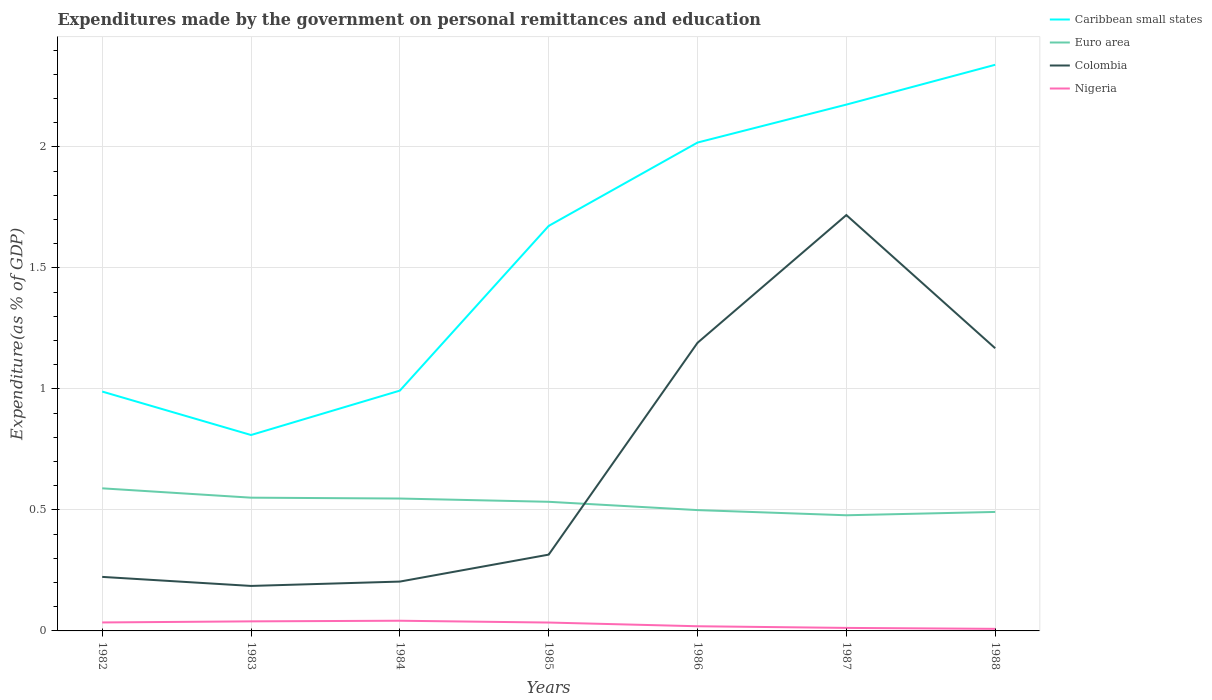Is the number of lines equal to the number of legend labels?
Provide a short and direct response. Yes. Across all years, what is the maximum expenditures made by the government on personal remittances and education in Nigeria?
Your answer should be compact. 0.01. In which year was the expenditures made by the government on personal remittances and education in Caribbean small states maximum?
Keep it short and to the point. 1983. What is the total expenditures made by the government on personal remittances and education in Colombia in the graph?
Offer a terse response. -1.4. What is the difference between the highest and the second highest expenditures made by the government on personal remittances and education in Euro area?
Provide a succinct answer. 0.11. How many years are there in the graph?
Your answer should be very brief. 7. What is the difference between two consecutive major ticks on the Y-axis?
Give a very brief answer. 0.5. Are the values on the major ticks of Y-axis written in scientific E-notation?
Offer a very short reply. No. Does the graph contain any zero values?
Your response must be concise. No. Where does the legend appear in the graph?
Ensure brevity in your answer.  Top right. How many legend labels are there?
Your answer should be compact. 4. What is the title of the graph?
Provide a short and direct response. Expenditures made by the government on personal remittances and education. What is the label or title of the Y-axis?
Make the answer very short. Expenditure(as % of GDP). What is the Expenditure(as % of GDP) in Caribbean small states in 1982?
Offer a very short reply. 0.99. What is the Expenditure(as % of GDP) of Euro area in 1982?
Offer a terse response. 0.59. What is the Expenditure(as % of GDP) in Colombia in 1982?
Provide a succinct answer. 0.22. What is the Expenditure(as % of GDP) in Nigeria in 1982?
Your response must be concise. 0.04. What is the Expenditure(as % of GDP) in Caribbean small states in 1983?
Your response must be concise. 0.81. What is the Expenditure(as % of GDP) in Euro area in 1983?
Provide a succinct answer. 0.55. What is the Expenditure(as % of GDP) in Colombia in 1983?
Make the answer very short. 0.19. What is the Expenditure(as % of GDP) of Nigeria in 1983?
Your response must be concise. 0.04. What is the Expenditure(as % of GDP) in Caribbean small states in 1984?
Provide a succinct answer. 0.99. What is the Expenditure(as % of GDP) of Euro area in 1984?
Ensure brevity in your answer.  0.55. What is the Expenditure(as % of GDP) of Colombia in 1984?
Make the answer very short. 0.2. What is the Expenditure(as % of GDP) in Nigeria in 1984?
Provide a succinct answer. 0.04. What is the Expenditure(as % of GDP) of Caribbean small states in 1985?
Your answer should be compact. 1.67. What is the Expenditure(as % of GDP) of Euro area in 1985?
Offer a terse response. 0.53. What is the Expenditure(as % of GDP) of Colombia in 1985?
Ensure brevity in your answer.  0.32. What is the Expenditure(as % of GDP) of Nigeria in 1985?
Provide a short and direct response. 0.03. What is the Expenditure(as % of GDP) in Caribbean small states in 1986?
Offer a terse response. 2.02. What is the Expenditure(as % of GDP) of Euro area in 1986?
Make the answer very short. 0.5. What is the Expenditure(as % of GDP) in Colombia in 1986?
Keep it short and to the point. 1.19. What is the Expenditure(as % of GDP) of Nigeria in 1986?
Give a very brief answer. 0.02. What is the Expenditure(as % of GDP) of Caribbean small states in 1987?
Offer a terse response. 2.17. What is the Expenditure(as % of GDP) in Euro area in 1987?
Your answer should be very brief. 0.48. What is the Expenditure(as % of GDP) of Colombia in 1987?
Your answer should be very brief. 1.72. What is the Expenditure(as % of GDP) in Nigeria in 1987?
Your answer should be very brief. 0.01. What is the Expenditure(as % of GDP) in Caribbean small states in 1988?
Provide a short and direct response. 2.34. What is the Expenditure(as % of GDP) in Euro area in 1988?
Your response must be concise. 0.49. What is the Expenditure(as % of GDP) of Colombia in 1988?
Your response must be concise. 1.17. What is the Expenditure(as % of GDP) in Nigeria in 1988?
Your answer should be very brief. 0.01. Across all years, what is the maximum Expenditure(as % of GDP) in Caribbean small states?
Your response must be concise. 2.34. Across all years, what is the maximum Expenditure(as % of GDP) of Euro area?
Your answer should be very brief. 0.59. Across all years, what is the maximum Expenditure(as % of GDP) in Colombia?
Keep it short and to the point. 1.72. Across all years, what is the maximum Expenditure(as % of GDP) of Nigeria?
Keep it short and to the point. 0.04. Across all years, what is the minimum Expenditure(as % of GDP) of Caribbean small states?
Make the answer very short. 0.81. Across all years, what is the minimum Expenditure(as % of GDP) in Euro area?
Offer a very short reply. 0.48. Across all years, what is the minimum Expenditure(as % of GDP) of Colombia?
Provide a succinct answer. 0.19. Across all years, what is the minimum Expenditure(as % of GDP) of Nigeria?
Make the answer very short. 0.01. What is the total Expenditure(as % of GDP) in Caribbean small states in the graph?
Provide a short and direct response. 11. What is the total Expenditure(as % of GDP) in Euro area in the graph?
Offer a terse response. 3.69. What is the total Expenditure(as % of GDP) of Colombia in the graph?
Offer a very short reply. 5.01. What is the total Expenditure(as % of GDP) in Nigeria in the graph?
Make the answer very short. 0.19. What is the difference between the Expenditure(as % of GDP) in Caribbean small states in 1982 and that in 1983?
Provide a succinct answer. 0.18. What is the difference between the Expenditure(as % of GDP) of Euro area in 1982 and that in 1983?
Offer a terse response. 0.04. What is the difference between the Expenditure(as % of GDP) of Colombia in 1982 and that in 1983?
Give a very brief answer. 0.04. What is the difference between the Expenditure(as % of GDP) in Nigeria in 1982 and that in 1983?
Offer a very short reply. -0. What is the difference between the Expenditure(as % of GDP) in Caribbean small states in 1982 and that in 1984?
Provide a short and direct response. -0. What is the difference between the Expenditure(as % of GDP) in Euro area in 1982 and that in 1984?
Ensure brevity in your answer.  0.04. What is the difference between the Expenditure(as % of GDP) in Colombia in 1982 and that in 1984?
Ensure brevity in your answer.  0.02. What is the difference between the Expenditure(as % of GDP) of Nigeria in 1982 and that in 1984?
Your answer should be very brief. -0.01. What is the difference between the Expenditure(as % of GDP) of Caribbean small states in 1982 and that in 1985?
Offer a terse response. -0.68. What is the difference between the Expenditure(as % of GDP) in Euro area in 1982 and that in 1985?
Keep it short and to the point. 0.06. What is the difference between the Expenditure(as % of GDP) of Colombia in 1982 and that in 1985?
Offer a terse response. -0.09. What is the difference between the Expenditure(as % of GDP) of Caribbean small states in 1982 and that in 1986?
Make the answer very short. -1.03. What is the difference between the Expenditure(as % of GDP) in Euro area in 1982 and that in 1986?
Offer a terse response. 0.09. What is the difference between the Expenditure(as % of GDP) in Colombia in 1982 and that in 1986?
Offer a terse response. -0.97. What is the difference between the Expenditure(as % of GDP) of Nigeria in 1982 and that in 1986?
Offer a very short reply. 0.02. What is the difference between the Expenditure(as % of GDP) in Caribbean small states in 1982 and that in 1987?
Keep it short and to the point. -1.19. What is the difference between the Expenditure(as % of GDP) in Euro area in 1982 and that in 1987?
Your answer should be compact. 0.11. What is the difference between the Expenditure(as % of GDP) in Colombia in 1982 and that in 1987?
Ensure brevity in your answer.  -1.5. What is the difference between the Expenditure(as % of GDP) of Nigeria in 1982 and that in 1987?
Make the answer very short. 0.02. What is the difference between the Expenditure(as % of GDP) of Caribbean small states in 1982 and that in 1988?
Give a very brief answer. -1.35. What is the difference between the Expenditure(as % of GDP) in Euro area in 1982 and that in 1988?
Your response must be concise. 0.1. What is the difference between the Expenditure(as % of GDP) of Colombia in 1982 and that in 1988?
Keep it short and to the point. -0.94. What is the difference between the Expenditure(as % of GDP) in Nigeria in 1982 and that in 1988?
Your answer should be compact. 0.03. What is the difference between the Expenditure(as % of GDP) of Caribbean small states in 1983 and that in 1984?
Your answer should be very brief. -0.18. What is the difference between the Expenditure(as % of GDP) of Euro area in 1983 and that in 1984?
Provide a succinct answer. 0. What is the difference between the Expenditure(as % of GDP) in Colombia in 1983 and that in 1984?
Provide a short and direct response. -0.02. What is the difference between the Expenditure(as % of GDP) of Nigeria in 1983 and that in 1984?
Make the answer very short. -0. What is the difference between the Expenditure(as % of GDP) of Caribbean small states in 1983 and that in 1985?
Your answer should be compact. -0.86. What is the difference between the Expenditure(as % of GDP) in Euro area in 1983 and that in 1985?
Offer a very short reply. 0.02. What is the difference between the Expenditure(as % of GDP) in Colombia in 1983 and that in 1985?
Provide a succinct answer. -0.13. What is the difference between the Expenditure(as % of GDP) of Nigeria in 1983 and that in 1985?
Provide a succinct answer. 0. What is the difference between the Expenditure(as % of GDP) of Caribbean small states in 1983 and that in 1986?
Offer a very short reply. -1.21. What is the difference between the Expenditure(as % of GDP) of Euro area in 1983 and that in 1986?
Make the answer very short. 0.05. What is the difference between the Expenditure(as % of GDP) in Colombia in 1983 and that in 1986?
Provide a short and direct response. -1. What is the difference between the Expenditure(as % of GDP) of Nigeria in 1983 and that in 1986?
Keep it short and to the point. 0.02. What is the difference between the Expenditure(as % of GDP) of Caribbean small states in 1983 and that in 1987?
Make the answer very short. -1.37. What is the difference between the Expenditure(as % of GDP) of Euro area in 1983 and that in 1987?
Keep it short and to the point. 0.07. What is the difference between the Expenditure(as % of GDP) of Colombia in 1983 and that in 1987?
Your answer should be compact. -1.53. What is the difference between the Expenditure(as % of GDP) of Nigeria in 1983 and that in 1987?
Your response must be concise. 0.03. What is the difference between the Expenditure(as % of GDP) in Caribbean small states in 1983 and that in 1988?
Your answer should be very brief. -1.53. What is the difference between the Expenditure(as % of GDP) in Euro area in 1983 and that in 1988?
Your answer should be very brief. 0.06. What is the difference between the Expenditure(as % of GDP) in Colombia in 1983 and that in 1988?
Your answer should be very brief. -0.98. What is the difference between the Expenditure(as % of GDP) in Nigeria in 1983 and that in 1988?
Your answer should be compact. 0.03. What is the difference between the Expenditure(as % of GDP) of Caribbean small states in 1984 and that in 1985?
Your answer should be very brief. -0.68. What is the difference between the Expenditure(as % of GDP) in Euro area in 1984 and that in 1985?
Offer a very short reply. 0.01. What is the difference between the Expenditure(as % of GDP) in Colombia in 1984 and that in 1985?
Your answer should be very brief. -0.11. What is the difference between the Expenditure(as % of GDP) of Nigeria in 1984 and that in 1985?
Provide a short and direct response. 0.01. What is the difference between the Expenditure(as % of GDP) in Caribbean small states in 1984 and that in 1986?
Keep it short and to the point. -1.02. What is the difference between the Expenditure(as % of GDP) of Euro area in 1984 and that in 1986?
Ensure brevity in your answer.  0.05. What is the difference between the Expenditure(as % of GDP) in Colombia in 1984 and that in 1986?
Your answer should be compact. -0.99. What is the difference between the Expenditure(as % of GDP) in Nigeria in 1984 and that in 1986?
Make the answer very short. 0.02. What is the difference between the Expenditure(as % of GDP) of Caribbean small states in 1984 and that in 1987?
Your response must be concise. -1.18. What is the difference between the Expenditure(as % of GDP) of Euro area in 1984 and that in 1987?
Provide a short and direct response. 0.07. What is the difference between the Expenditure(as % of GDP) of Colombia in 1984 and that in 1987?
Keep it short and to the point. -1.51. What is the difference between the Expenditure(as % of GDP) in Nigeria in 1984 and that in 1987?
Provide a short and direct response. 0.03. What is the difference between the Expenditure(as % of GDP) in Caribbean small states in 1984 and that in 1988?
Provide a succinct answer. -1.35. What is the difference between the Expenditure(as % of GDP) in Euro area in 1984 and that in 1988?
Provide a succinct answer. 0.06. What is the difference between the Expenditure(as % of GDP) of Colombia in 1984 and that in 1988?
Keep it short and to the point. -0.96. What is the difference between the Expenditure(as % of GDP) of Nigeria in 1984 and that in 1988?
Provide a succinct answer. 0.03. What is the difference between the Expenditure(as % of GDP) in Caribbean small states in 1985 and that in 1986?
Your answer should be very brief. -0.34. What is the difference between the Expenditure(as % of GDP) in Euro area in 1985 and that in 1986?
Provide a short and direct response. 0.03. What is the difference between the Expenditure(as % of GDP) in Colombia in 1985 and that in 1986?
Ensure brevity in your answer.  -0.88. What is the difference between the Expenditure(as % of GDP) in Nigeria in 1985 and that in 1986?
Your response must be concise. 0.02. What is the difference between the Expenditure(as % of GDP) of Caribbean small states in 1985 and that in 1987?
Offer a terse response. -0.5. What is the difference between the Expenditure(as % of GDP) of Euro area in 1985 and that in 1987?
Your response must be concise. 0.06. What is the difference between the Expenditure(as % of GDP) of Colombia in 1985 and that in 1987?
Offer a very short reply. -1.4. What is the difference between the Expenditure(as % of GDP) of Nigeria in 1985 and that in 1987?
Offer a terse response. 0.02. What is the difference between the Expenditure(as % of GDP) of Caribbean small states in 1985 and that in 1988?
Give a very brief answer. -0.67. What is the difference between the Expenditure(as % of GDP) in Euro area in 1985 and that in 1988?
Your response must be concise. 0.04. What is the difference between the Expenditure(as % of GDP) in Colombia in 1985 and that in 1988?
Your response must be concise. -0.85. What is the difference between the Expenditure(as % of GDP) of Nigeria in 1985 and that in 1988?
Your answer should be compact. 0.03. What is the difference between the Expenditure(as % of GDP) of Caribbean small states in 1986 and that in 1987?
Give a very brief answer. -0.16. What is the difference between the Expenditure(as % of GDP) in Euro area in 1986 and that in 1987?
Provide a short and direct response. 0.02. What is the difference between the Expenditure(as % of GDP) in Colombia in 1986 and that in 1987?
Your response must be concise. -0.53. What is the difference between the Expenditure(as % of GDP) of Nigeria in 1986 and that in 1987?
Make the answer very short. 0.01. What is the difference between the Expenditure(as % of GDP) of Caribbean small states in 1986 and that in 1988?
Your answer should be compact. -0.32. What is the difference between the Expenditure(as % of GDP) in Euro area in 1986 and that in 1988?
Keep it short and to the point. 0.01. What is the difference between the Expenditure(as % of GDP) of Colombia in 1986 and that in 1988?
Offer a terse response. 0.02. What is the difference between the Expenditure(as % of GDP) in Nigeria in 1986 and that in 1988?
Your answer should be very brief. 0.01. What is the difference between the Expenditure(as % of GDP) in Caribbean small states in 1987 and that in 1988?
Offer a terse response. -0.16. What is the difference between the Expenditure(as % of GDP) of Euro area in 1987 and that in 1988?
Provide a short and direct response. -0.01. What is the difference between the Expenditure(as % of GDP) in Colombia in 1987 and that in 1988?
Offer a very short reply. 0.55. What is the difference between the Expenditure(as % of GDP) of Nigeria in 1987 and that in 1988?
Provide a succinct answer. 0. What is the difference between the Expenditure(as % of GDP) of Caribbean small states in 1982 and the Expenditure(as % of GDP) of Euro area in 1983?
Provide a short and direct response. 0.44. What is the difference between the Expenditure(as % of GDP) in Caribbean small states in 1982 and the Expenditure(as % of GDP) in Colombia in 1983?
Provide a succinct answer. 0.8. What is the difference between the Expenditure(as % of GDP) in Caribbean small states in 1982 and the Expenditure(as % of GDP) in Nigeria in 1983?
Offer a terse response. 0.95. What is the difference between the Expenditure(as % of GDP) of Euro area in 1982 and the Expenditure(as % of GDP) of Colombia in 1983?
Your response must be concise. 0.4. What is the difference between the Expenditure(as % of GDP) of Euro area in 1982 and the Expenditure(as % of GDP) of Nigeria in 1983?
Offer a very short reply. 0.55. What is the difference between the Expenditure(as % of GDP) in Colombia in 1982 and the Expenditure(as % of GDP) in Nigeria in 1983?
Offer a very short reply. 0.18. What is the difference between the Expenditure(as % of GDP) of Caribbean small states in 1982 and the Expenditure(as % of GDP) of Euro area in 1984?
Offer a very short reply. 0.44. What is the difference between the Expenditure(as % of GDP) of Caribbean small states in 1982 and the Expenditure(as % of GDP) of Colombia in 1984?
Ensure brevity in your answer.  0.79. What is the difference between the Expenditure(as % of GDP) of Caribbean small states in 1982 and the Expenditure(as % of GDP) of Nigeria in 1984?
Provide a succinct answer. 0.95. What is the difference between the Expenditure(as % of GDP) of Euro area in 1982 and the Expenditure(as % of GDP) of Colombia in 1984?
Offer a very short reply. 0.39. What is the difference between the Expenditure(as % of GDP) in Euro area in 1982 and the Expenditure(as % of GDP) in Nigeria in 1984?
Provide a short and direct response. 0.55. What is the difference between the Expenditure(as % of GDP) of Colombia in 1982 and the Expenditure(as % of GDP) of Nigeria in 1984?
Make the answer very short. 0.18. What is the difference between the Expenditure(as % of GDP) in Caribbean small states in 1982 and the Expenditure(as % of GDP) in Euro area in 1985?
Ensure brevity in your answer.  0.46. What is the difference between the Expenditure(as % of GDP) in Caribbean small states in 1982 and the Expenditure(as % of GDP) in Colombia in 1985?
Provide a short and direct response. 0.67. What is the difference between the Expenditure(as % of GDP) of Caribbean small states in 1982 and the Expenditure(as % of GDP) of Nigeria in 1985?
Keep it short and to the point. 0.95. What is the difference between the Expenditure(as % of GDP) in Euro area in 1982 and the Expenditure(as % of GDP) in Colombia in 1985?
Your answer should be compact. 0.27. What is the difference between the Expenditure(as % of GDP) in Euro area in 1982 and the Expenditure(as % of GDP) in Nigeria in 1985?
Keep it short and to the point. 0.55. What is the difference between the Expenditure(as % of GDP) of Colombia in 1982 and the Expenditure(as % of GDP) of Nigeria in 1985?
Provide a short and direct response. 0.19. What is the difference between the Expenditure(as % of GDP) in Caribbean small states in 1982 and the Expenditure(as % of GDP) in Euro area in 1986?
Ensure brevity in your answer.  0.49. What is the difference between the Expenditure(as % of GDP) of Caribbean small states in 1982 and the Expenditure(as % of GDP) of Colombia in 1986?
Ensure brevity in your answer.  -0.2. What is the difference between the Expenditure(as % of GDP) of Caribbean small states in 1982 and the Expenditure(as % of GDP) of Nigeria in 1986?
Provide a succinct answer. 0.97. What is the difference between the Expenditure(as % of GDP) in Euro area in 1982 and the Expenditure(as % of GDP) in Colombia in 1986?
Your answer should be compact. -0.6. What is the difference between the Expenditure(as % of GDP) in Euro area in 1982 and the Expenditure(as % of GDP) in Nigeria in 1986?
Your response must be concise. 0.57. What is the difference between the Expenditure(as % of GDP) of Colombia in 1982 and the Expenditure(as % of GDP) of Nigeria in 1986?
Offer a very short reply. 0.2. What is the difference between the Expenditure(as % of GDP) of Caribbean small states in 1982 and the Expenditure(as % of GDP) of Euro area in 1987?
Ensure brevity in your answer.  0.51. What is the difference between the Expenditure(as % of GDP) in Caribbean small states in 1982 and the Expenditure(as % of GDP) in Colombia in 1987?
Your answer should be compact. -0.73. What is the difference between the Expenditure(as % of GDP) of Caribbean small states in 1982 and the Expenditure(as % of GDP) of Nigeria in 1987?
Offer a very short reply. 0.98. What is the difference between the Expenditure(as % of GDP) of Euro area in 1982 and the Expenditure(as % of GDP) of Colombia in 1987?
Provide a succinct answer. -1.13. What is the difference between the Expenditure(as % of GDP) of Euro area in 1982 and the Expenditure(as % of GDP) of Nigeria in 1987?
Make the answer very short. 0.58. What is the difference between the Expenditure(as % of GDP) of Colombia in 1982 and the Expenditure(as % of GDP) of Nigeria in 1987?
Your response must be concise. 0.21. What is the difference between the Expenditure(as % of GDP) in Caribbean small states in 1982 and the Expenditure(as % of GDP) in Euro area in 1988?
Offer a very short reply. 0.5. What is the difference between the Expenditure(as % of GDP) of Caribbean small states in 1982 and the Expenditure(as % of GDP) of Colombia in 1988?
Offer a very short reply. -0.18. What is the difference between the Expenditure(as % of GDP) of Caribbean small states in 1982 and the Expenditure(as % of GDP) of Nigeria in 1988?
Your response must be concise. 0.98. What is the difference between the Expenditure(as % of GDP) of Euro area in 1982 and the Expenditure(as % of GDP) of Colombia in 1988?
Your response must be concise. -0.58. What is the difference between the Expenditure(as % of GDP) of Euro area in 1982 and the Expenditure(as % of GDP) of Nigeria in 1988?
Ensure brevity in your answer.  0.58. What is the difference between the Expenditure(as % of GDP) of Colombia in 1982 and the Expenditure(as % of GDP) of Nigeria in 1988?
Make the answer very short. 0.21. What is the difference between the Expenditure(as % of GDP) of Caribbean small states in 1983 and the Expenditure(as % of GDP) of Euro area in 1984?
Offer a terse response. 0.26. What is the difference between the Expenditure(as % of GDP) of Caribbean small states in 1983 and the Expenditure(as % of GDP) of Colombia in 1984?
Your answer should be compact. 0.61. What is the difference between the Expenditure(as % of GDP) in Caribbean small states in 1983 and the Expenditure(as % of GDP) in Nigeria in 1984?
Make the answer very short. 0.77. What is the difference between the Expenditure(as % of GDP) of Euro area in 1983 and the Expenditure(as % of GDP) of Colombia in 1984?
Provide a short and direct response. 0.35. What is the difference between the Expenditure(as % of GDP) in Euro area in 1983 and the Expenditure(as % of GDP) in Nigeria in 1984?
Your answer should be compact. 0.51. What is the difference between the Expenditure(as % of GDP) of Colombia in 1983 and the Expenditure(as % of GDP) of Nigeria in 1984?
Your response must be concise. 0.14. What is the difference between the Expenditure(as % of GDP) of Caribbean small states in 1983 and the Expenditure(as % of GDP) of Euro area in 1985?
Give a very brief answer. 0.28. What is the difference between the Expenditure(as % of GDP) in Caribbean small states in 1983 and the Expenditure(as % of GDP) in Colombia in 1985?
Your answer should be very brief. 0.49. What is the difference between the Expenditure(as % of GDP) of Caribbean small states in 1983 and the Expenditure(as % of GDP) of Nigeria in 1985?
Keep it short and to the point. 0.77. What is the difference between the Expenditure(as % of GDP) in Euro area in 1983 and the Expenditure(as % of GDP) in Colombia in 1985?
Make the answer very short. 0.24. What is the difference between the Expenditure(as % of GDP) of Euro area in 1983 and the Expenditure(as % of GDP) of Nigeria in 1985?
Ensure brevity in your answer.  0.52. What is the difference between the Expenditure(as % of GDP) in Colombia in 1983 and the Expenditure(as % of GDP) in Nigeria in 1985?
Offer a very short reply. 0.15. What is the difference between the Expenditure(as % of GDP) in Caribbean small states in 1983 and the Expenditure(as % of GDP) in Euro area in 1986?
Provide a succinct answer. 0.31. What is the difference between the Expenditure(as % of GDP) of Caribbean small states in 1983 and the Expenditure(as % of GDP) of Colombia in 1986?
Keep it short and to the point. -0.38. What is the difference between the Expenditure(as % of GDP) of Caribbean small states in 1983 and the Expenditure(as % of GDP) of Nigeria in 1986?
Your response must be concise. 0.79. What is the difference between the Expenditure(as % of GDP) of Euro area in 1983 and the Expenditure(as % of GDP) of Colombia in 1986?
Make the answer very short. -0.64. What is the difference between the Expenditure(as % of GDP) in Euro area in 1983 and the Expenditure(as % of GDP) in Nigeria in 1986?
Offer a very short reply. 0.53. What is the difference between the Expenditure(as % of GDP) in Colombia in 1983 and the Expenditure(as % of GDP) in Nigeria in 1986?
Keep it short and to the point. 0.17. What is the difference between the Expenditure(as % of GDP) in Caribbean small states in 1983 and the Expenditure(as % of GDP) in Euro area in 1987?
Ensure brevity in your answer.  0.33. What is the difference between the Expenditure(as % of GDP) in Caribbean small states in 1983 and the Expenditure(as % of GDP) in Colombia in 1987?
Keep it short and to the point. -0.91. What is the difference between the Expenditure(as % of GDP) in Caribbean small states in 1983 and the Expenditure(as % of GDP) in Nigeria in 1987?
Give a very brief answer. 0.8. What is the difference between the Expenditure(as % of GDP) of Euro area in 1983 and the Expenditure(as % of GDP) of Colombia in 1987?
Your answer should be very brief. -1.17. What is the difference between the Expenditure(as % of GDP) in Euro area in 1983 and the Expenditure(as % of GDP) in Nigeria in 1987?
Provide a succinct answer. 0.54. What is the difference between the Expenditure(as % of GDP) of Colombia in 1983 and the Expenditure(as % of GDP) of Nigeria in 1987?
Give a very brief answer. 0.17. What is the difference between the Expenditure(as % of GDP) of Caribbean small states in 1983 and the Expenditure(as % of GDP) of Euro area in 1988?
Provide a short and direct response. 0.32. What is the difference between the Expenditure(as % of GDP) of Caribbean small states in 1983 and the Expenditure(as % of GDP) of Colombia in 1988?
Offer a very short reply. -0.36. What is the difference between the Expenditure(as % of GDP) of Caribbean small states in 1983 and the Expenditure(as % of GDP) of Nigeria in 1988?
Make the answer very short. 0.8. What is the difference between the Expenditure(as % of GDP) of Euro area in 1983 and the Expenditure(as % of GDP) of Colombia in 1988?
Provide a short and direct response. -0.62. What is the difference between the Expenditure(as % of GDP) in Euro area in 1983 and the Expenditure(as % of GDP) in Nigeria in 1988?
Offer a very short reply. 0.54. What is the difference between the Expenditure(as % of GDP) in Colombia in 1983 and the Expenditure(as % of GDP) in Nigeria in 1988?
Give a very brief answer. 0.18. What is the difference between the Expenditure(as % of GDP) of Caribbean small states in 1984 and the Expenditure(as % of GDP) of Euro area in 1985?
Keep it short and to the point. 0.46. What is the difference between the Expenditure(as % of GDP) of Caribbean small states in 1984 and the Expenditure(as % of GDP) of Colombia in 1985?
Your answer should be compact. 0.68. What is the difference between the Expenditure(as % of GDP) of Caribbean small states in 1984 and the Expenditure(as % of GDP) of Nigeria in 1985?
Offer a terse response. 0.96. What is the difference between the Expenditure(as % of GDP) of Euro area in 1984 and the Expenditure(as % of GDP) of Colombia in 1985?
Keep it short and to the point. 0.23. What is the difference between the Expenditure(as % of GDP) in Euro area in 1984 and the Expenditure(as % of GDP) in Nigeria in 1985?
Provide a short and direct response. 0.51. What is the difference between the Expenditure(as % of GDP) of Colombia in 1984 and the Expenditure(as % of GDP) of Nigeria in 1985?
Provide a succinct answer. 0.17. What is the difference between the Expenditure(as % of GDP) in Caribbean small states in 1984 and the Expenditure(as % of GDP) in Euro area in 1986?
Offer a terse response. 0.49. What is the difference between the Expenditure(as % of GDP) of Caribbean small states in 1984 and the Expenditure(as % of GDP) of Colombia in 1986?
Provide a short and direct response. -0.2. What is the difference between the Expenditure(as % of GDP) of Caribbean small states in 1984 and the Expenditure(as % of GDP) of Nigeria in 1986?
Make the answer very short. 0.97. What is the difference between the Expenditure(as % of GDP) in Euro area in 1984 and the Expenditure(as % of GDP) in Colombia in 1986?
Your answer should be compact. -0.64. What is the difference between the Expenditure(as % of GDP) of Euro area in 1984 and the Expenditure(as % of GDP) of Nigeria in 1986?
Give a very brief answer. 0.53. What is the difference between the Expenditure(as % of GDP) in Colombia in 1984 and the Expenditure(as % of GDP) in Nigeria in 1986?
Keep it short and to the point. 0.18. What is the difference between the Expenditure(as % of GDP) of Caribbean small states in 1984 and the Expenditure(as % of GDP) of Euro area in 1987?
Keep it short and to the point. 0.52. What is the difference between the Expenditure(as % of GDP) of Caribbean small states in 1984 and the Expenditure(as % of GDP) of Colombia in 1987?
Provide a succinct answer. -0.73. What is the difference between the Expenditure(as % of GDP) in Caribbean small states in 1984 and the Expenditure(as % of GDP) in Nigeria in 1987?
Offer a terse response. 0.98. What is the difference between the Expenditure(as % of GDP) of Euro area in 1984 and the Expenditure(as % of GDP) of Colombia in 1987?
Ensure brevity in your answer.  -1.17. What is the difference between the Expenditure(as % of GDP) in Euro area in 1984 and the Expenditure(as % of GDP) in Nigeria in 1987?
Keep it short and to the point. 0.53. What is the difference between the Expenditure(as % of GDP) of Colombia in 1984 and the Expenditure(as % of GDP) of Nigeria in 1987?
Keep it short and to the point. 0.19. What is the difference between the Expenditure(as % of GDP) in Caribbean small states in 1984 and the Expenditure(as % of GDP) in Euro area in 1988?
Provide a short and direct response. 0.5. What is the difference between the Expenditure(as % of GDP) of Caribbean small states in 1984 and the Expenditure(as % of GDP) of Colombia in 1988?
Keep it short and to the point. -0.18. What is the difference between the Expenditure(as % of GDP) of Caribbean small states in 1984 and the Expenditure(as % of GDP) of Nigeria in 1988?
Make the answer very short. 0.98. What is the difference between the Expenditure(as % of GDP) in Euro area in 1984 and the Expenditure(as % of GDP) in Colombia in 1988?
Offer a terse response. -0.62. What is the difference between the Expenditure(as % of GDP) in Euro area in 1984 and the Expenditure(as % of GDP) in Nigeria in 1988?
Provide a succinct answer. 0.54. What is the difference between the Expenditure(as % of GDP) of Colombia in 1984 and the Expenditure(as % of GDP) of Nigeria in 1988?
Keep it short and to the point. 0.2. What is the difference between the Expenditure(as % of GDP) in Caribbean small states in 1985 and the Expenditure(as % of GDP) in Euro area in 1986?
Make the answer very short. 1.17. What is the difference between the Expenditure(as % of GDP) in Caribbean small states in 1985 and the Expenditure(as % of GDP) in Colombia in 1986?
Offer a terse response. 0.48. What is the difference between the Expenditure(as % of GDP) in Caribbean small states in 1985 and the Expenditure(as % of GDP) in Nigeria in 1986?
Keep it short and to the point. 1.65. What is the difference between the Expenditure(as % of GDP) of Euro area in 1985 and the Expenditure(as % of GDP) of Colombia in 1986?
Ensure brevity in your answer.  -0.66. What is the difference between the Expenditure(as % of GDP) in Euro area in 1985 and the Expenditure(as % of GDP) in Nigeria in 1986?
Keep it short and to the point. 0.51. What is the difference between the Expenditure(as % of GDP) in Colombia in 1985 and the Expenditure(as % of GDP) in Nigeria in 1986?
Your answer should be compact. 0.3. What is the difference between the Expenditure(as % of GDP) of Caribbean small states in 1985 and the Expenditure(as % of GDP) of Euro area in 1987?
Keep it short and to the point. 1.2. What is the difference between the Expenditure(as % of GDP) in Caribbean small states in 1985 and the Expenditure(as % of GDP) in Colombia in 1987?
Offer a terse response. -0.04. What is the difference between the Expenditure(as % of GDP) in Caribbean small states in 1985 and the Expenditure(as % of GDP) in Nigeria in 1987?
Your response must be concise. 1.66. What is the difference between the Expenditure(as % of GDP) of Euro area in 1985 and the Expenditure(as % of GDP) of Colombia in 1987?
Your answer should be compact. -1.18. What is the difference between the Expenditure(as % of GDP) in Euro area in 1985 and the Expenditure(as % of GDP) in Nigeria in 1987?
Provide a succinct answer. 0.52. What is the difference between the Expenditure(as % of GDP) in Colombia in 1985 and the Expenditure(as % of GDP) in Nigeria in 1987?
Give a very brief answer. 0.3. What is the difference between the Expenditure(as % of GDP) in Caribbean small states in 1985 and the Expenditure(as % of GDP) in Euro area in 1988?
Keep it short and to the point. 1.18. What is the difference between the Expenditure(as % of GDP) in Caribbean small states in 1985 and the Expenditure(as % of GDP) in Colombia in 1988?
Make the answer very short. 0.51. What is the difference between the Expenditure(as % of GDP) of Caribbean small states in 1985 and the Expenditure(as % of GDP) of Nigeria in 1988?
Your response must be concise. 1.66. What is the difference between the Expenditure(as % of GDP) in Euro area in 1985 and the Expenditure(as % of GDP) in Colombia in 1988?
Provide a succinct answer. -0.63. What is the difference between the Expenditure(as % of GDP) of Euro area in 1985 and the Expenditure(as % of GDP) of Nigeria in 1988?
Offer a very short reply. 0.52. What is the difference between the Expenditure(as % of GDP) of Colombia in 1985 and the Expenditure(as % of GDP) of Nigeria in 1988?
Your response must be concise. 0.31. What is the difference between the Expenditure(as % of GDP) in Caribbean small states in 1986 and the Expenditure(as % of GDP) in Euro area in 1987?
Provide a succinct answer. 1.54. What is the difference between the Expenditure(as % of GDP) of Caribbean small states in 1986 and the Expenditure(as % of GDP) of Colombia in 1987?
Your answer should be very brief. 0.3. What is the difference between the Expenditure(as % of GDP) of Caribbean small states in 1986 and the Expenditure(as % of GDP) of Nigeria in 1987?
Make the answer very short. 2.01. What is the difference between the Expenditure(as % of GDP) in Euro area in 1986 and the Expenditure(as % of GDP) in Colombia in 1987?
Your answer should be compact. -1.22. What is the difference between the Expenditure(as % of GDP) in Euro area in 1986 and the Expenditure(as % of GDP) in Nigeria in 1987?
Give a very brief answer. 0.49. What is the difference between the Expenditure(as % of GDP) in Colombia in 1986 and the Expenditure(as % of GDP) in Nigeria in 1987?
Provide a short and direct response. 1.18. What is the difference between the Expenditure(as % of GDP) of Caribbean small states in 1986 and the Expenditure(as % of GDP) of Euro area in 1988?
Provide a short and direct response. 1.53. What is the difference between the Expenditure(as % of GDP) in Caribbean small states in 1986 and the Expenditure(as % of GDP) in Colombia in 1988?
Your answer should be very brief. 0.85. What is the difference between the Expenditure(as % of GDP) in Caribbean small states in 1986 and the Expenditure(as % of GDP) in Nigeria in 1988?
Your answer should be very brief. 2.01. What is the difference between the Expenditure(as % of GDP) of Euro area in 1986 and the Expenditure(as % of GDP) of Colombia in 1988?
Your response must be concise. -0.67. What is the difference between the Expenditure(as % of GDP) of Euro area in 1986 and the Expenditure(as % of GDP) of Nigeria in 1988?
Your response must be concise. 0.49. What is the difference between the Expenditure(as % of GDP) in Colombia in 1986 and the Expenditure(as % of GDP) in Nigeria in 1988?
Give a very brief answer. 1.18. What is the difference between the Expenditure(as % of GDP) in Caribbean small states in 1987 and the Expenditure(as % of GDP) in Euro area in 1988?
Your response must be concise. 1.68. What is the difference between the Expenditure(as % of GDP) in Caribbean small states in 1987 and the Expenditure(as % of GDP) in Colombia in 1988?
Provide a short and direct response. 1.01. What is the difference between the Expenditure(as % of GDP) of Caribbean small states in 1987 and the Expenditure(as % of GDP) of Nigeria in 1988?
Your response must be concise. 2.17. What is the difference between the Expenditure(as % of GDP) in Euro area in 1987 and the Expenditure(as % of GDP) in Colombia in 1988?
Make the answer very short. -0.69. What is the difference between the Expenditure(as % of GDP) in Euro area in 1987 and the Expenditure(as % of GDP) in Nigeria in 1988?
Your response must be concise. 0.47. What is the difference between the Expenditure(as % of GDP) in Colombia in 1987 and the Expenditure(as % of GDP) in Nigeria in 1988?
Make the answer very short. 1.71. What is the average Expenditure(as % of GDP) in Caribbean small states per year?
Offer a terse response. 1.57. What is the average Expenditure(as % of GDP) in Euro area per year?
Give a very brief answer. 0.53. What is the average Expenditure(as % of GDP) of Colombia per year?
Offer a very short reply. 0.71. What is the average Expenditure(as % of GDP) of Nigeria per year?
Your answer should be very brief. 0.03. In the year 1982, what is the difference between the Expenditure(as % of GDP) of Caribbean small states and Expenditure(as % of GDP) of Euro area?
Offer a terse response. 0.4. In the year 1982, what is the difference between the Expenditure(as % of GDP) in Caribbean small states and Expenditure(as % of GDP) in Colombia?
Make the answer very short. 0.77. In the year 1982, what is the difference between the Expenditure(as % of GDP) in Caribbean small states and Expenditure(as % of GDP) in Nigeria?
Your answer should be compact. 0.95. In the year 1982, what is the difference between the Expenditure(as % of GDP) in Euro area and Expenditure(as % of GDP) in Colombia?
Keep it short and to the point. 0.37. In the year 1982, what is the difference between the Expenditure(as % of GDP) of Euro area and Expenditure(as % of GDP) of Nigeria?
Offer a very short reply. 0.55. In the year 1982, what is the difference between the Expenditure(as % of GDP) in Colombia and Expenditure(as % of GDP) in Nigeria?
Your response must be concise. 0.19. In the year 1983, what is the difference between the Expenditure(as % of GDP) in Caribbean small states and Expenditure(as % of GDP) in Euro area?
Give a very brief answer. 0.26. In the year 1983, what is the difference between the Expenditure(as % of GDP) in Caribbean small states and Expenditure(as % of GDP) in Colombia?
Give a very brief answer. 0.62. In the year 1983, what is the difference between the Expenditure(as % of GDP) of Caribbean small states and Expenditure(as % of GDP) of Nigeria?
Your answer should be compact. 0.77. In the year 1983, what is the difference between the Expenditure(as % of GDP) of Euro area and Expenditure(as % of GDP) of Colombia?
Keep it short and to the point. 0.36. In the year 1983, what is the difference between the Expenditure(as % of GDP) of Euro area and Expenditure(as % of GDP) of Nigeria?
Provide a succinct answer. 0.51. In the year 1983, what is the difference between the Expenditure(as % of GDP) in Colombia and Expenditure(as % of GDP) in Nigeria?
Keep it short and to the point. 0.15. In the year 1984, what is the difference between the Expenditure(as % of GDP) in Caribbean small states and Expenditure(as % of GDP) in Euro area?
Your answer should be very brief. 0.45. In the year 1984, what is the difference between the Expenditure(as % of GDP) of Caribbean small states and Expenditure(as % of GDP) of Colombia?
Ensure brevity in your answer.  0.79. In the year 1984, what is the difference between the Expenditure(as % of GDP) of Caribbean small states and Expenditure(as % of GDP) of Nigeria?
Provide a succinct answer. 0.95. In the year 1984, what is the difference between the Expenditure(as % of GDP) of Euro area and Expenditure(as % of GDP) of Colombia?
Give a very brief answer. 0.34. In the year 1984, what is the difference between the Expenditure(as % of GDP) in Euro area and Expenditure(as % of GDP) in Nigeria?
Offer a terse response. 0.5. In the year 1984, what is the difference between the Expenditure(as % of GDP) in Colombia and Expenditure(as % of GDP) in Nigeria?
Your answer should be compact. 0.16. In the year 1985, what is the difference between the Expenditure(as % of GDP) of Caribbean small states and Expenditure(as % of GDP) of Euro area?
Offer a very short reply. 1.14. In the year 1985, what is the difference between the Expenditure(as % of GDP) of Caribbean small states and Expenditure(as % of GDP) of Colombia?
Provide a succinct answer. 1.36. In the year 1985, what is the difference between the Expenditure(as % of GDP) in Caribbean small states and Expenditure(as % of GDP) in Nigeria?
Your response must be concise. 1.64. In the year 1985, what is the difference between the Expenditure(as % of GDP) of Euro area and Expenditure(as % of GDP) of Colombia?
Offer a terse response. 0.22. In the year 1985, what is the difference between the Expenditure(as % of GDP) in Euro area and Expenditure(as % of GDP) in Nigeria?
Make the answer very short. 0.5. In the year 1985, what is the difference between the Expenditure(as % of GDP) of Colombia and Expenditure(as % of GDP) of Nigeria?
Keep it short and to the point. 0.28. In the year 1986, what is the difference between the Expenditure(as % of GDP) of Caribbean small states and Expenditure(as % of GDP) of Euro area?
Make the answer very short. 1.52. In the year 1986, what is the difference between the Expenditure(as % of GDP) in Caribbean small states and Expenditure(as % of GDP) in Colombia?
Offer a very short reply. 0.83. In the year 1986, what is the difference between the Expenditure(as % of GDP) of Caribbean small states and Expenditure(as % of GDP) of Nigeria?
Ensure brevity in your answer.  2. In the year 1986, what is the difference between the Expenditure(as % of GDP) of Euro area and Expenditure(as % of GDP) of Colombia?
Offer a very short reply. -0.69. In the year 1986, what is the difference between the Expenditure(as % of GDP) in Euro area and Expenditure(as % of GDP) in Nigeria?
Offer a very short reply. 0.48. In the year 1986, what is the difference between the Expenditure(as % of GDP) of Colombia and Expenditure(as % of GDP) of Nigeria?
Your response must be concise. 1.17. In the year 1987, what is the difference between the Expenditure(as % of GDP) of Caribbean small states and Expenditure(as % of GDP) of Euro area?
Keep it short and to the point. 1.7. In the year 1987, what is the difference between the Expenditure(as % of GDP) of Caribbean small states and Expenditure(as % of GDP) of Colombia?
Keep it short and to the point. 0.46. In the year 1987, what is the difference between the Expenditure(as % of GDP) in Caribbean small states and Expenditure(as % of GDP) in Nigeria?
Ensure brevity in your answer.  2.16. In the year 1987, what is the difference between the Expenditure(as % of GDP) in Euro area and Expenditure(as % of GDP) in Colombia?
Offer a terse response. -1.24. In the year 1987, what is the difference between the Expenditure(as % of GDP) of Euro area and Expenditure(as % of GDP) of Nigeria?
Keep it short and to the point. 0.47. In the year 1987, what is the difference between the Expenditure(as % of GDP) of Colombia and Expenditure(as % of GDP) of Nigeria?
Offer a terse response. 1.71. In the year 1988, what is the difference between the Expenditure(as % of GDP) in Caribbean small states and Expenditure(as % of GDP) in Euro area?
Give a very brief answer. 1.85. In the year 1988, what is the difference between the Expenditure(as % of GDP) in Caribbean small states and Expenditure(as % of GDP) in Colombia?
Ensure brevity in your answer.  1.17. In the year 1988, what is the difference between the Expenditure(as % of GDP) in Caribbean small states and Expenditure(as % of GDP) in Nigeria?
Make the answer very short. 2.33. In the year 1988, what is the difference between the Expenditure(as % of GDP) of Euro area and Expenditure(as % of GDP) of Colombia?
Your response must be concise. -0.68. In the year 1988, what is the difference between the Expenditure(as % of GDP) in Euro area and Expenditure(as % of GDP) in Nigeria?
Offer a terse response. 0.48. In the year 1988, what is the difference between the Expenditure(as % of GDP) in Colombia and Expenditure(as % of GDP) in Nigeria?
Your answer should be very brief. 1.16. What is the ratio of the Expenditure(as % of GDP) of Caribbean small states in 1982 to that in 1983?
Ensure brevity in your answer.  1.22. What is the ratio of the Expenditure(as % of GDP) of Euro area in 1982 to that in 1983?
Your answer should be compact. 1.07. What is the ratio of the Expenditure(as % of GDP) in Colombia in 1982 to that in 1983?
Offer a terse response. 1.2. What is the ratio of the Expenditure(as % of GDP) in Nigeria in 1982 to that in 1983?
Your answer should be compact. 0.89. What is the ratio of the Expenditure(as % of GDP) in Caribbean small states in 1982 to that in 1984?
Offer a terse response. 1. What is the ratio of the Expenditure(as % of GDP) in Euro area in 1982 to that in 1984?
Ensure brevity in your answer.  1.08. What is the ratio of the Expenditure(as % of GDP) of Colombia in 1982 to that in 1984?
Give a very brief answer. 1.09. What is the ratio of the Expenditure(as % of GDP) in Nigeria in 1982 to that in 1984?
Provide a short and direct response. 0.83. What is the ratio of the Expenditure(as % of GDP) of Caribbean small states in 1982 to that in 1985?
Provide a succinct answer. 0.59. What is the ratio of the Expenditure(as % of GDP) of Euro area in 1982 to that in 1985?
Make the answer very short. 1.1. What is the ratio of the Expenditure(as % of GDP) in Colombia in 1982 to that in 1985?
Ensure brevity in your answer.  0.71. What is the ratio of the Expenditure(as % of GDP) of Nigeria in 1982 to that in 1985?
Offer a terse response. 1.01. What is the ratio of the Expenditure(as % of GDP) of Caribbean small states in 1982 to that in 1986?
Provide a succinct answer. 0.49. What is the ratio of the Expenditure(as % of GDP) in Euro area in 1982 to that in 1986?
Make the answer very short. 1.18. What is the ratio of the Expenditure(as % of GDP) of Colombia in 1982 to that in 1986?
Provide a succinct answer. 0.19. What is the ratio of the Expenditure(as % of GDP) of Nigeria in 1982 to that in 1986?
Offer a very short reply. 1.81. What is the ratio of the Expenditure(as % of GDP) of Caribbean small states in 1982 to that in 1987?
Make the answer very short. 0.45. What is the ratio of the Expenditure(as % of GDP) in Euro area in 1982 to that in 1987?
Your answer should be very brief. 1.23. What is the ratio of the Expenditure(as % of GDP) in Colombia in 1982 to that in 1987?
Make the answer very short. 0.13. What is the ratio of the Expenditure(as % of GDP) of Nigeria in 1982 to that in 1987?
Make the answer very short. 2.81. What is the ratio of the Expenditure(as % of GDP) of Caribbean small states in 1982 to that in 1988?
Offer a very short reply. 0.42. What is the ratio of the Expenditure(as % of GDP) in Euro area in 1982 to that in 1988?
Make the answer very short. 1.2. What is the ratio of the Expenditure(as % of GDP) of Colombia in 1982 to that in 1988?
Make the answer very short. 0.19. What is the ratio of the Expenditure(as % of GDP) of Nigeria in 1982 to that in 1988?
Provide a short and direct response. 4.08. What is the ratio of the Expenditure(as % of GDP) of Caribbean small states in 1983 to that in 1984?
Make the answer very short. 0.82. What is the ratio of the Expenditure(as % of GDP) of Colombia in 1983 to that in 1984?
Your answer should be compact. 0.91. What is the ratio of the Expenditure(as % of GDP) in Nigeria in 1983 to that in 1984?
Your answer should be compact. 0.94. What is the ratio of the Expenditure(as % of GDP) in Caribbean small states in 1983 to that in 1985?
Keep it short and to the point. 0.48. What is the ratio of the Expenditure(as % of GDP) of Euro area in 1983 to that in 1985?
Offer a terse response. 1.03. What is the ratio of the Expenditure(as % of GDP) of Colombia in 1983 to that in 1985?
Ensure brevity in your answer.  0.59. What is the ratio of the Expenditure(as % of GDP) in Nigeria in 1983 to that in 1985?
Ensure brevity in your answer.  1.14. What is the ratio of the Expenditure(as % of GDP) in Caribbean small states in 1983 to that in 1986?
Your answer should be very brief. 0.4. What is the ratio of the Expenditure(as % of GDP) of Euro area in 1983 to that in 1986?
Offer a very short reply. 1.1. What is the ratio of the Expenditure(as % of GDP) in Colombia in 1983 to that in 1986?
Make the answer very short. 0.16. What is the ratio of the Expenditure(as % of GDP) of Nigeria in 1983 to that in 1986?
Provide a short and direct response. 2.05. What is the ratio of the Expenditure(as % of GDP) in Caribbean small states in 1983 to that in 1987?
Make the answer very short. 0.37. What is the ratio of the Expenditure(as % of GDP) of Euro area in 1983 to that in 1987?
Ensure brevity in your answer.  1.15. What is the ratio of the Expenditure(as % of GDP) in Colombia in 1983 to that in 1987?
Make the answer very short. 0.11. What is the ratio of the Expenditure(as % of GDP) of Nigeria in 1983 to that in 1987?
Your answer should be very brief. 3.17. What is the ratio of the Expenditure(as % of GDP) in Caribbean small states in 1983 to that in 1988?
Provide a short and direct response. 0.35. What is the ratio of the Expenditure(as % of GDP) in Euro area in 1983 to that in 1988?
Your answer should be very brief. 1.12. What is the ratio of the Expenditure(as % of GDP) in Colombia in 1983 to that in 1988?
Offer a terse response. 0.16. What is the ratio of the Expenditure(as % of GDP) in Nigeria in 1983 to that in 1988?
Your answer should be compact. 4.6. What is the ratio of the Expenditure(as % of GDP) of Caribbean small states in 1984 to that in 1985?
Your answer should be very brief. 0.59. What is the ratio of the Expenditure(as % of GDP) of Euro area in 1984 to that in 1985?
Your answer should be compact. 1.03. What is the ratio of the Expenditure(as % of GDP) in Colombia in 1984 to that in 1985?
Your answer should be very brief. 0.65. What is the ratio of the Expenditure(as % of GDP) in Nigeria in 1984 to that in 1985?
Your answer should be compact. 1.22. What is the ratio of the Expenditure(as % of GDP) of Caribbean small states in 1984 to that in 1986?
Offer a very short reply. 0.49. What is the ratio of the Expenditure(as % of GDP) of Euro area in 1984 to that in 1986?
Make the answer very short. 1.1. What is the ratio of the Expenditure(as % of GDP) in Colombia in 1984 to that in 1986?
Provide a short and direct response. 0.17. What is the ratio of the Expenditure(as % of GDP) in Nigeria in 1984 to that in 1986?
Provide a short and direct response. 2.18. What is the ratio of the Expenditure(as % of GDP) in Caribbean small states in 1984 to that in 1987?
Offer a terse response. 0.46. What is the ratio of the Expenditure(as % of GDP) in Euro area in 1984 to that in 1987?
Offer a very short reply. 1.14. What is the ratio of the Expenditure(as % of GDP) of Colombia in 1984 to that in 1987?
Offer a very short reply. 0.12. What is the ratio of the Expenditure(as % of GDP) of Nigeria in 1984 to that in 1987?
Make the answer very short. 3.38. What is the ratio of the Expenditure(as % of GDP) in Caribbean small states in 1984 to that in 1988?
Provide a succinct answer. 0.42. What is the ratio of the Expenditure(as % of GDP) in Euro area in 1984 to that in 1988?
Keep it short and to the point. 1.11. What is the ratio of the Expenditure(as % of GDP) of Colombia in 1984 to that in 1988?
Your response must be concise. 0.17. What is the ratio of the Expenditure(as % of GDP) in Nigeria in 1984 to that in 1988?
Offer a very short reply. 4.9. What is the ratio of the Expenditure(as % of GDP) in Caribbean small states in 1985 to that in 1986?
Your answer should be very brief. 0.83. What is the ratio of the Expenditure(as % of GDP) of Euro area in 1985 to that in 1986?
Ensure brevity in your answer.  1.07. What is the ratio of the Expenditure(as % of GDP) in Colombia in 1985 to that in 1986?
Keep it short and to the point. 0.26. What is the ratio of the Expenditure(as % of GDP) in Nigeria in 1985 to that in 1986?
Provide a succinct answer. 1.79. What is the ratio of the Expenditure(as % of GDP) in Caribbean small states in 1985 to that in 1987?
Your answer should be very brief. 0.77. What is the ratio of the Expenditure(as % of GDP) of Euro area in 1985 to that in 1987?
Your answer should be compact. 1.12. What is the ratio of the Expenditure(as % of GDP) of Colombia in 1985 to that in 1987?
Ensure brevity in your answer.  0.18. What is the ratio of the Expenditure(as % of GDP) of Nigeria in 1985 to that in 1987?
Keep it short and to the point. 2.78. What is the ratio of the Expenditure(as % of GDP) in Caribbean small states in 1985 to that in 1988?
Your response must be concise. 0.72. What is the ratio of the Expenditure(as % of GDP) in Euro area in 1985 to that in 1988?
Your answer should be compact. 1.09. What is the ratio of the Expenditure(as % of GDP) of Colombia in 1985 to that in 1988?
Your answer should be compact. 0.27. What is the ratio of the Expenditure(as % of GDP) in Nigeria in 1985 to that in 1988?
Ensure brevity in your answer.  4.03. What is the ratio of the Expenditure(as % of GDP) in Caribbean small states in 1986 to that in 1987?
Your answer should be very brief. 0.93. What is the ratio of the Expenditure(as % of GDP) of Euro area in 1986 to that in 1987?
Make the answer very short. 1.04. What is the ratio of the Expenditure(as % of GDP) of Colombia in 1986 to that in 1987?
Give a very brief answer. 0.69. What is the ratio of the Expenditure(as % of GDP) in Nigeria in 1986 to that in 1987?
Provide a short and direct response. 1.55. What is the ratio of the Expenditure(as % of GDP) of Caribbean small states in 1986 to that in 1988?
Offer a terse response. 0.86. What is the ratio of the Expenditure(as % of GDP) of Euro area in 1986 to that in 1988?
Give a very brief answer. 1.02. What is the ratio of the Expenditure(as % of GDP) of Colombia in 1986 to that in 1988?
Keep it short and to the point. 1.02. What is the ratio of the Expenditure(as % of GDP) in Nigeria in 1986 to that in 1988?
Give a very brief answer. 2.25. What is the ratio of the Expenditure(as % of GDP) in Caribbean small states in 1987 to that in 1988?
Make the answer very short. 0.93. What is the ratio of the Expenditure(as % of GDP) of Euro area in 1987 to that in 1988?
Offer a terse response. 0.97. What is the ratio of the Expenditure(as % of GDP) in Colombia in 1987 to that in 1988?
Give a very brief answer. 1.47. What is the ratio of the Expenditure(as % of GDP) of Nigeria in 1987 to that in 1988?
Provide a succinct answer. 1.45. What is the difference between the highest and the second highest Expenditure(as % of GDP) of Caribbean small states?
Your answer should be very brief. 0.16. What is the difference between the highest and the second highest Expenditure(as % of GDP) of Euro area?
Your answer should be compact. 0.04. What is the difference between the highest and the second highest Expenditure(as % of GDP) in Colombia?
Provide a short and direct response. 0.53. What is the difference between the highest and the second highest Expenditure(as % of GDP) in Nigeria?
Make the answer very short. 0. What is the difference between the highest and the lowest Expenditure(as % of GDP) in Caribbean small states?
Offer a terse response. 1.53. What is the difference between the highest and the lowest Expenditure(as % of GDP) in Euro area?
Offer a very short reply. 0.11. What is the difference between the highest and the lowest Expenditure(as % of GDP) in Colombia?
Make the answer very short. 1.53. What is the difference between the highest and the lowest Expenditure(as % of GDP) of Nigeria?
Your answer should be compact. 0.03. 